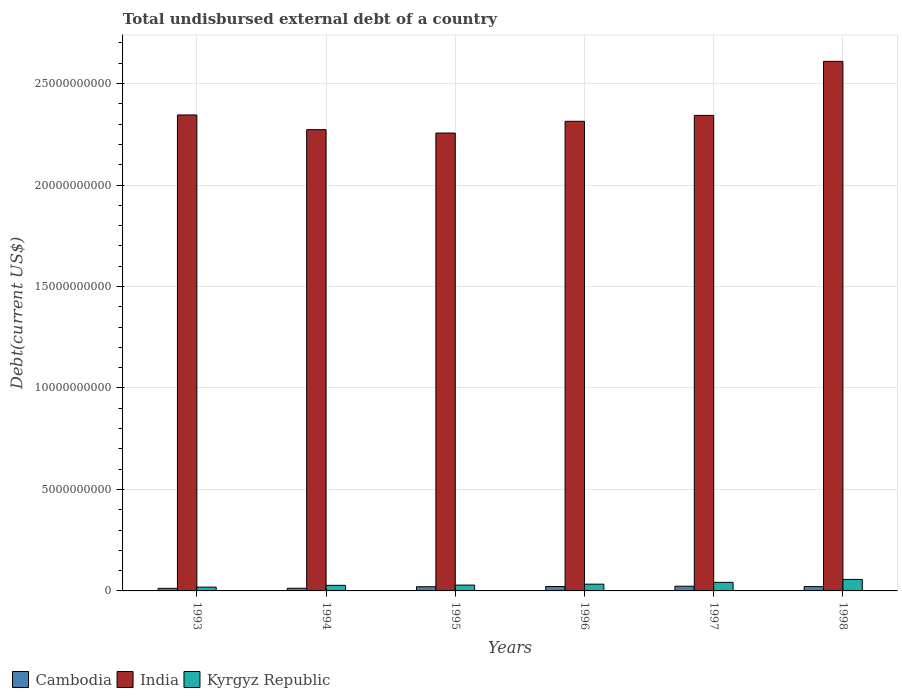How many different coloured bars are there?
Make the answer very short. 3. Are the number of bars per tick equal to the number of legend labels?
Offer a terse response. Yes. How many bars are there on the 3rd tick from the right?
Your answer should be compact. 3. What is the total undisbursed external debt in India in 1997?
Your answer should be very brief. 2.34e+1. Across all years, what is the maximum total undisbursed external debt in India?
Offer a terse response. 2.61e+1. Across all years, what is the minimum total undisbursed external debt in India?
Ensure brevity in your answer.  2.26e+1. In which year was the total undisbursed external debt in Kyrgyz Republic maximum?
Provide a short and direct response. 1998. In which year was the total undisbursed external debt in Cambodia minimum?
Give a very brief answer. 1993. What is the total total undisbursed external debt in India in the graph?
Give a very brief answer. 1.41e+11. What is the difference between the total undisbursed external debt in India in 1995 and that in 1998?
Your answer should be very brief. -3.53e+09. What is the difference between the total undisbursed external debt in Kyrgyz Republic in 1993 and the total undisbursed external debt in Cambodia in 1997?
Ensure brevity in your answer.  -4.32e+07. What is the average total undisbursed external debt in India per year?
Your answer should be compact. 2.36e+1. In the year 1993, what is the difference between the total undisbursed external debt in Kyrgyz Republic and total undisbursed external debt in Cambodia?
Your response must be concise. 6.01e+07. In how many years, is the total undisbursed external debt in Cambodia greater than 24000000000 US$?
Make the answer very short. 0. What is the ratio of the total undisbursed external debt in Cambodia in 1996 to that in 1998?
Give a very brief answer. 1.01. Is the total undisbursed external debt in Cambodia in 1994 less than that in 1998?
Your answer should be compact. Yes. Is the difference between the total undisbursed external debt in Kyrgyz Republic in 1997 and 1998 greater than the difference between the total undisbursed external debt in Cambodia in 1997 and 1998?
Give a very brief answer. No. What is the difference between the highest and the second highest total undisbursed external debt in India?
Offer a terse response. 2.64e+09. What is the difference between the highest and the lowest total undisbursed external debt in India?
Your answer should be compact. 3.53e+09. In how many years, is the total undisbursed external debt in India greater than the average total undisbursed external debt in India taken over all years?
Keep it short and to the point. 1. Is the sum of the total undisbursed external debt in India in 1994 and 1998 greater than the maximum total undisbursed external debt in Cambodia across all years?
Provide a short and direct response. Yes. What does the 1st bar from the left in 1993 represents?
Offer a very short reply. Cambodia. What does the 1st bar from the right in 1994 represents?
Provide a short and direct response. Kyrgyz Republic. Is it the case that in every year, the sum of the total undisbursed external debt in India and total undisbursed external debt in Cambodia is greater than the total undisbursed external debt in Kyrgyz Republic?
Your response must be concise. Yes. How many bars are there?
Provide a succinct answer. 18. Does the graph contain any zero values?
Your answer should be very brief. No. How many legend labels are there?
Provide a succinct answer. 3. What is the title of the graph?
Your answer should be compact. Total undisbursed external debt of a country. What is the label or title of the Y-axis?
Give a very brief answer. Debt(current US$). What is the Debt(current US$) of Cambodia in 1993?
Ensure brevity in your answer.  1.28e+08. What is the Debt(current US$) of India in 1993?
Ensure brevity in your answer.  2.35e+1. What is the Debt(current US$) of Kyrgyz Republic in 1993?
Keep it short and to the point. 1.88e+08. What is the Debt(current US$) in Cambodia in 1994?
Your answer should be very brief. 1.31e+08. What is the Debt(current US$) of India in 1994?
Your response must be concise. 2.27e+1. What is the Debt(current US$) in Kyrgyz Republic in 1994?
Make the answer very short. 2.75e+08. What is the Debt(current US$) in Cambodia in 1995?
Ensure brevity in your answer.  2.06e+08. What is the Debt(current US$) of India in 1995?
Provide a short and direct response. 2.26e+1. What is the Debt(current US$) of Kyrgyz Republic in 1995?
Ensure brevity in your answer.  2.88e+08. What is the Debt(current US$) of Cambodia in 1996?
Make the answer very short. 2.16e+08. What is the Debt(current US$) of India in 1996?
Your answer should be compact. 2.31e+1. What is the Debt(current US$) of Kyrgyz Republic in 1996?
Offer a very short reply. 3.33e+08. What is the Debt(current US$) of Cambodia in 1997?
Make the answer very short. 2.31e+08. What is the Debt(current US$) in India in 1997?
Provide a short and direct response. 2.34e+1. What is the Debt(current US$) in Kyrgyz Republic in 1997?
Provide a succinct answer. 4.22e+08. What is the Debt(current US$) in Cambodia in 1998?
Ensure brevity in your answer.  2.14e+08. What is the Debt(current US$) of India in 1998?
Your answer should be very brief. 2.61e+1. What is the Debt(current US$) in Kyrgyz Republic in 1998?
Your answer should be very brief. 5.67e+08. Across all years, what is the maximum Debt(current US$) in Cambodia?
Offer a terse response. 2.31e+08. Across all years, what is the maximum Debt(current US$) in India?
Your answer should be very brief. 2.61e+1. Across all years, what is the maximum Debt(current US$) of Kyrgyz Republic?
Ensure brevity in your answer.  5.67e+08. Across all years, what is the minimum Debt(current US$) in Cambodia?
Ensure brevity in your answer.  1.28e+08. Across all years, what is the minimum Debt(current US$) of India?
Your answer should be compact. 2.26e+1. Across all years, what is the minimum Debt(current US$) of Kyrgyz Republic?
Ensure brevity in your answer.  1.88e+08. What is the total Debt(current US$) of Cambodia in the graph?
Provide a short and direct response. 1.13e+09. What is the total Debt(current US$) in India in the graph?
Offer a very short reply. 1.41e+11. What is the total Debt(current US$) in Kyrgyz Republic in the graph?
Your answer should be compact. 2.07e+09. What is the difference between the Debt(current US$) of Cambodia in 1993 and that in 1994?
Offer a terse response. -3.66e+06. What is the difference between the Debt(current US$) of India in 1993 and that in 1994?
Offer a very short reply. 7.24e+08. What is the difference between the Debt(current US$) of Kyrgyz Republic in 1993 and that in 1994?
Offer a very short reply. -8.71e+07. What is the difference between the Debt(current US$) in Cambodia in 1993 and that in 1995?
Offer a very short reply. -7.79e+07. What is the difference between the Debt(current US$) in India in 1993 and that in 1995?
Provide a short and direct response. 8.91e+08. What is the difference between the Debt(current US$) of Kyrgyz Republic in 1993 and that in 1995?
Keep it short and to the point. -9.99e+07. What is the difference between the Debt(current US$) of Cambodia in 1993 and that in 1996?
Offer a terse response. -8.86e+07. What is the difference between the Debt(current US$) of India in 1993 and that in 1996?
Offer a terse response. 3.13e+08. What is the difference between the Debt(current US$) of Kyrgyz Republic in 1993 and that in 1996?
Your answer should be compact. -1.45e+08. What is the difference between the Debt(current US$) of Cambodia in 1993 and that in 1997?
Make the answer very short. -1.03e+08. What is the difference between the Debt(current US$) in India in 1993 and that in 1997?
Your response must be concise. 2.13e+07. What is the difference between the Debt(current US$) in Kyrgyz Republic in 1993 and that in 1997?
Provide a short and direct response. -2.35e+08. What is the difference between the Debt(current US$) in Cambodia in 1993 and that in 1998?
Your answer should be compact. -8.59e+07. What is the difference between the Debt(current US$) of India in 1993 and that in 1998?
Your answer should be compact. -2.64e+09. What is the difference between the Debt(current US$) in Kyrgyz Republic in 1993 and that in 1998?
Your answer should be very brief. -3.79e+08. What is the difference between the Debt(current US$) of Cambodia in 1994 and that in 1995?
Offer a very short reply. -7.42e+07. What is the difference between the Debt(current US$) of India in 1994 and that in 1995?
Give a very brief answer. 1.67e+08. What is the difference between the Debt(current US$) in Kyrgyz Republic in 1994 and that in 1995?
Keep it short and to the point. -1.28e+07. What is the difference between the Debt(current US$) of Cambodia in 1994 and that in 1996?
Your response must be concise. -8.50e+07. What is the difference between the Debt(current US$) in India in 1994 and that in 1996?
Ensure brevity in your answer.  -4.11e+08. What is the difference between the Debt(current US$) of Kyrgyz Republic in 1994 and that in 1996?
Your answer should be very brief. -5.80e+07. What is the difference between the Debt(current US$) of Cambodia in 1994 and that in 1997?
Offer a terse response. -9.96e+07. What is the difference between the Debt(current US$) in India in 1994 and that in 1997?
Give a very brief answer. -7.03e+08. What is the difference between the Debt(current US$) in Kyrgyz Republic in 1994 and that in 1997?
Offer a terse response. -1.48e+08. What is the difference between the Debt(current US$) of Cambodia in 1994 and that in 1998?
Make the answer very short. -8.22e+07. What is the difference between the Debt(current US$) of India in 1994 and that in 1998?
Provide a succinct answer. -3.37e+09. What is the difference between the Debt(current US$) in Kyrgyz Republic in 1994 and that in 1998?
Provide a succinct answer. -2.92e+08. What is the difference between the Debt(current US$) of Cambodia in 1995 and that in 1996?
Offer a very short reply. -1.07e+07. What is the difference between the Debt(current US$) of India in 1995 and that in 1996?
Keep it short and to the point. -5.79e+08. What is the difference between the Debt(current US$) of Kyrgyz Republic in 1995 and that in 1996?
Offer a terse response. -4.52e+07. What is the difference between the Debt(current US$) of Cambodia in 1995 and that in 1997?
Provide a succinct answer. -2.54e+07. What is the difference between the Debt(current US$) of India in 1995 and that in 1997?
Offer a terse response. -8.70e+08. What is the difference between the Debt(current US$) of Kyrgyz Republic in 1995 and that in 1997?
Keep it short and to the point. -1.35e+08. What is the difference between the Debt(current US$) in Cambodia in 1995 and that in 1998?
Make the answer very short. -7.99e+06. What is the difference between the Debt(current US$) of India in 1995 and that in 1998?
Give a very brief answer. -3.53e+09. What is the difference between the Debt(current US$) of Kyrgyz Republic in 1995 and that in 1998?
Your response must be concise. -2.79e+08. What is the difference between the Debt(current US$) in Cambodia in 1996 and that in 1997?
Make the answer very short. -1.47e+07. What is the difference between the Debt(current US$) of India in 1996 and that in 1997?
Keep it short and to the point. -2.91e+08. What is the difference between the Debt(current US$) in Kyrgyz Republic in 1996 and that in 1997?
Your response must be concise. -8.95e+07. What is the difference between the Debt(current US$) in Cambodia in 1996 and that in 1998?
Offer a terse response. 2.73e+06. What is the difference between the Debt(current US$) of India in 1996 and that in 1998?
Your answer should be compact. -2.95e+09. What is the difference between the Debt(current US$) in Kyrgyz Republic in 1996 and that in 1998?
Provide a succinct answer. -2.34e+08. What is the difference between the Debt(current US$) of Cambodia in 1997 and that in 1998?
Offer a very short reply. 1.74e+07. What is the difference between the Debt(current US$) of India in 1997 and that in 1998?
Your answer should be compact. -2.66e+09. What is the difference between the Debt(current US$) in Kyrgyz Republic in 1997 and that in 1998?
Keep it short and to the point. -1.44e+08. What is the difference between the Debt(current US$) of Cambodia in 1993 and the Debt(current US$) of India in 1994?
Make the answer very short. -2.26e+1. What is the difference between the Debt(current US$) of Cambodia in 1993 and the Debt(current US$) of Kyrgyz Republic in 1994?
Offer a terse response. -1.47e+08. What is the difference between the Debt(current US$) of India in 1993 and the Debt(current US$) of Kyrgyz Republic in 1994?
Provide a short and direct response. 2.32e+1. What is the difference between the Debt(current US$) of Cambodia in 1993 and the Debt(current US$) of India in 1995?
Offer a terse response. -2.24e+1. What is the difference between the Debt(current US$) in Cambodia in 1993 and the Debt(current US$) in Kyrgyz Republic in 1995?
Ensure brevity in your answer.  -1.60e+08. What is the difference between the Debt(current US$) in India in 1993 and the Debt(current US$) in Kyrgyz Republic in 1995?
Offer a terse response. 2.32e+1. What is the difference between the Debt(current US$) in Cambodia in 1993 and the Debt(current US$) in India in 1996?
Make the answer very short. -2.30e+1. What is the difference between the Debt(current US$) in Cambodia in 1993 and the Debt(current US$) in Kyrgyz Republic in 1996?
Give a very brief answer. -2.05e+08. What is the difference between the Debt(current US$) of India in 1993 and the Debt(current US$) of Kyrgyz Republic in 1996?
Provide a short and direct response. 2.31e+1. What is the difference between the Debt(current US$) in Cambodia in 1993 and the Debt(current US$) in India in 1997?
Offer a very short reply. -2.33e+1. What is the difference between the Debt(current US$) in Cambodia in 1993 and the Debt(current US$) in Kyrgyz Republic in 1997?
Your answer should be very brief. -2.95e+08. What is the difference between the Debt(current US$) of India in 1993 and the Debt(current US$) of Kyrgyz Republic in 1997?
Give a very brief answer. 2.30e+1. What is the difference between the Debt(current US$) of Cambodia in 1993 and the Debt(current US$) of India in 1998?
Offer a terse response. -2.60e+1. What is the difference between the Debt(current US$) of Cambodia in 1993 and the Debt(current US$) of Kyrgyz Republic in 1998?
Offer a very short reply. -4.39e+08. What is the difference between the Debt(current US$) in India in 1993 and the Debt(current US$) in Kyrgyz Republic in 1998?
Offer a terse response. 2.29e+1. What is the difference between the Debt(current US$) of Cambodia in 1994 and the Debt(current US$) of India in 1995?
Your answer should be compact. -2.24e+1. What is the difference between the Debt(current US$) of Cambodia in 1994 and the Debt(current US$) of Kyrgyz Republic in 1995?
Give a very brief answer. -1.56e+08. What is the difference between the Debt(current US$) in India in 1994 and the Debt(current US$) in Kyrgyz Republic in 1995?
Give a very brief answer. 2.24e+1. What is the difference between the Debt(current US$) of Cambodia in 1994 and the Debt(current US$) of India in 1996?
Your answer should be very brief. -2.30e+1. What is the difference between the Debt(current US$) of Cambodia in 1994 and the Debt(current US$) of Kyrgyz Republic in 1996?
Provide a short and direct response. -2.02e+08. What is the difference between the Debt(current US$) of India in 1994 and the Debt(current US$) of Kyrgyz Republic in 1996?
Offer a terse response. 2.24e+1. What is the difference between the Debt(current US$) of Cambodia in 1994 and the Debt(current US$) of India in 1997?
Offer a very short reply. -2.33e+1. What is the difference between the Debt(current US$) in Cambodia in 1994 and the Debt(current US$) in Kyrgyz Republic in 1997?
Provide a succinct answer. -2.91e+08. What is the difference between the Debt(current US$) of India in 1994 and the Debt(current US$) of Kyrgyz Republic in 1997?
Your response must be concise. 2.23e+1. What is the difference between the Debt(current US$) in Cambodia in 1994 and the Debt(current US$) in India in 1998?
Offer a terse response. -2.60e+1. What is the difference between the Debt(current US$) in Cambodia in 1994 and the Debt(current US$) in Kyrgyz Republic in 1998?
Give a very brief answer. -4.36e+08. What is the difference between the Debt(current US$) of India in 1994 and the Debt(current US$) of Kyrgyz Republic in 1998?
Your answer should be very brief. 2.22e+1. What is the difference between the Debt(current US$) of Cambodia in 1995 and the Debt(current US$) of India in 1996?
Provide a succinct answer. -2.29e+1. What is the difference between the Debt(current US$) in Cambodia in 1995 and the Debt(current US$) in Kyrgyz Republic in 1996?
Keep it short and to the point. -1.27e+08. What is the difference between the Debt(current US$) in India in 1995 and the Debt(current US$) in Kyrgyz Republic in 1996?
Your answer should be very brief. 2.22e+1. What is the difference between the Debt(current US$) of Cambodia in 1995 and the Debt(current US$) of India in 1997?
Offer a terse response. -2.32e+1. What is the difference between the Debt(current US$) of Cambodia in 1995 and the Debt(current US$) of Kyrgyz Republic in 1997?
Give a very brief answer. -2.17e+08. What is the difference between the Debt(current US$) in India in 1995 and the Debt(current US$) in Kyrgyz Republic in 1997?
Offer a terse response. 2.21e+1. What is the difference between the Debt(current US$) in Cambodia in 1995 and the Debt(current US$) in India in 1998?
Ensure brevity in your answer.  -2.59e+1. What is the difference between the Debt(current US$) of Cambodia in 1995 and the Debt(current US$) of Kyrgyz Republic in 1998?
Your response must be concise. -3.61e+08. What is the difference between the Debt(current US$) in India in 1995 and the Debt(current US$) in Kyrgyz Republic in 1998?
Provide a succinct answer. 2.20e+1. What is the difference between the Debt(current US$) of Cambodia in 1996 and the Debt(current US$) of India in 1997?
Give a very brief answer. -2.32e+1. What is the difference between the Debt(current US$) in Cambodia in 1996 and the Debt(current US$) in Kyrgyz Republic in 1997?
Make the answer very short. -2.06e+08. What is the difference between the Debt(current US$) of India in 1996 and the Debt(current US$) of Kyrgyz Republic in 1997?
Your response must be concise. 2.27e+1. What is the difference between the Debt(current US$) in Cambodia in 1996 and the Debt(current US$) in India in 1998?
Offer a terse response. -2.59e+1. What is the difference between the Debt(current US$) in Cambodia in 1996 and the Debt(current US$) in Kyrgyz Republic in 1998?
Offer a very short reply. -3.51e+08. What is the difference between the Debt(current US$) in India in 1996 and the Debt(current US$) in Kyrgyz Republic in 1998?
Provide a succinct answer. 2.26e+1. What is the difference between the Debt(current US$) of Cambodia in 1997 and the Debt(current US$) of India in 1998?
Give a very brief answer. -2.59e+1. What is the difference between the Debt(current US$) in Cambodia in 1997 and the Debt(current US$) in Kyrgyz Republic in 1998?
Keep it short and to the point. -3.36e+08. What is the difference between the Debt(current US$) of India in 1997 and the Debt(current US$) of Kyrgyz Republic in 1998?
Offer a terse response. 2.29e+1. What is the average Debt(current US$) of Cambodia per year?
Offer a very short reply. 1.88e+08. What is the average Debt(current US$) in India per year?
Your answer should be compact. 2.36e+1. What is the average Debt(current US$) in Kyrgyz Republic per year?
Your response must be concise. 3.45e+08. In the year 1993, what is the difference between the Debt(current US$) in Cambodia and Debt(current US$) in India?
Keep it short and to the point. -2.33e+1. In the year 1993, what is the difference between the Debt(current US$) in Cambodia and Debt(current US$) in Kyrgyz Republic?
Your answer should be very brief. -6.01e+07. In the year 1993, what is the difference between the Debt(current US$) in India and Debt(current US$) in Kyrgyz Republic?
Ensure brevity in your answer.  2.33e+1. In the year 1994, what is the difference between the Debt(current US$) of Cambodia and Debt(current US$) of India?
Keep it short and to the point. -2.26e+1. In the year 1994, what is the difference between the Debt(current US$) in Cambodia and Debt(current US$) in Kyrgyz Republic?
Make the answer very short. -1.43e+08. In the year 1994, what is the difference between the Debt(current US$) of India and Debt(current US$) of Kyrgyz Republic?
Your answer should be very brief. 2.25e+1. In the year 1995, what is the difference between the Debt(current US$) in Cambodia and Debt(current US$) in India?
Provide a succinct answer. -2.24e+1. In the year 1995, what is the difference between the Debt(current US$) in Cambodia and Debt(current US$) in Kyrgyz Republic?
Provide a short and direct response. -8.21e+07. In the year 1995, what is the difference between the Debt(current US$) in India and Debt(current US$) in Kyrgyz Republic?
Provide a short and direct response. 2.23e+1. In the year 1996, what is the difference between the Debt(current US$) of Cambodia and Debt(current US$) of India?
Offer a very short reply. -2.29e+1. In the year 1996, what is the difference between the Debt(current US$) of Cambodia and Debt(current US$) of Kyrgyz Republic?
Your response must be concise. -1.17e+08. In the year 1996, what is the difference between the Debt(current US$) in India and Debt(current US$) in Kyrgyz Republic?
Your answer should be compact. 2.28e+1. In the year 1997, what is the difference between the Debt(current US$) of Cambodia and Debt(current US$) of India?
Offer a terse response. -2.32e+1. In the year 1997, what is the difference between the Debt(current US$) in Cambodia and Debt(current US$) in Kyrgyz Republic?
Keep it short and to the point. -1.91e+08. In the year 1997, what is the difference between the Debt(current US$) of India and Debt(current US$) of Kyrgyz Republic?
Provide a succinct answer. 2.30e+1. In the year 1998, what is the difference between the Debt(current US$) of Cambodia and Debt(current US$) of India?
Keep it short and to the point. -2.59e+1. In the year 1998, what is the difference between the Debt(current US$) in Cambodia and Debt(current US$) in Kyrgyz Republic?
Provide a short and direct response. -3.53e+08. In the year 1998, what is the difference between the Debt(current US$) in India and Debt(current US$) in Kyrgyz Republic?
Give a very brief answer. 2.55e+1. What is the ratio of the Debt(current US$) in Cambodia in 1993 to that in 1994?
Give a very brief answer. 0.97. What is the ratio of the Debt(current US$) of India in 1993 to that in 1994?
Your answer should be compact. 1.03. What is the ratio of the Debt(current US$) in Kyrgyz Republic in 1993 to that in 1994?
Your answer should be very brief. 0.68. What is the ratio of the Debt(current US$) in Cambodia in 1993 to that in 1995?
Ensure brevity in your answer.  0.62. What is the ratio of the Debt(current US$) in India in 1993 to that in 1995?
Your response must be concise. 1.04. What is the ratio of the Debt(current US$) of Kyrgyz Republic in 1993 to that in 1995?
Provide a succinct answer. 0.65. What is the ratio of the Debt(current US$) in Cambodia in 1993 to that in 1996?
Give a very brief answer. 0.59. What is the ratio of the Debt(current US$) in India in 1993 to that in 1996?
Provide a succinct answer. 1.01. What is the ratio of the Debt(current US$) of Kyrgyz Republic in 1993 to that in 1996?
Make the answer very short. 0.56. What is the ratio of the Debt(current US$) in Cambodia in 1993 to that in 1997?
Your answer should be very brief. 0.55. What is the ratio of the Debt(current US$) of Kyrgyz Republic in 1993 to that in 1997?
Give a very brief answer. 0.44. What is the ratio of the Debt(current US$) of Cambodia in 1993 to that in 1998?
Offer a very short reply. 0.6. What is the ratio of the Debt(current US$) of India in 1993 to that in 1998?
Make the answer very short. 0.9. What is the ratio of the Debt(current US$) in Kyrgyz Republic in 1993 to that in 1998?
Your response must be concise. 0.33. What is the ratio of the Debt(current US$) in Cambodia in 1994 to that in 1995?
Provide a short and direct response. 0.64. What is the ratio of the Debt(current US$) of India in 1994 to that in 1995?
Provide a short and direct response. 1.01. What is the ratio of the Debt(current US$) of Kyrgyz Republic in 1994 to that in 1995?
Provide a succinct answer. 0.96. What is the ratio of the Debt(current US$) in Cambodia in 1994 to that in 1996?
Provide a short and direct response. 0.61. What is the ratio of the Debt(current US$) in India in 1994 to that in 1996?
Your answer should be compact. 0.98. What is the ratio of the Debt(current US$) in Kyrgyz Republic in 1994 to that in 1996?
Give a very brief answer. 0.83. What is the ratio of the Debt(current US$) of Cambodia in 1994 to that in 1997?
Provide a succinct answer. 0.57. What is the ratio of the Debt(current US$) in India in 1994 to that in 1997?
Keep it short and to the point. 0.97. What is the ratio of the Debt(current US$) of Kyrgyz Republic in 1994 to that in 1997?
Offer a terse response. 0.65. What is the ratio of the Debt(current US$) of Cambodia in 1994 to that in 1998?
Your answer should be very brief. 0.62. What is the ratio of the Debt(current US$) in India in 1994 to that in 1998?
Your answer should be compact. 0.87. What is the ratio of the Debt(current US$) in Kyrgyz Republic in 1994 to that in 1998?
Keep it short and to the point. 0.48. What is the ratio of the Debt(current US$) of Cambodia in 1995 to that in 1996?
Your answer should be very brief. 0.95. What is the ratio of the Debt(current US$) in Kyrgyz Republic in 1995 to that in 1996?
Your response must be concise. 0.86. What is the ratio of the Debt(current US$) of Cambodia in 1995 to that in 1997?
Your answer should be very brief. 0.89. What is the ratio of the Debt(current US$) of India in 1995 to that in 1997?
Offer a very short reply. 0.96. What is the ratio of the Debt(current US$) in Kyrgyz Republic in 1995 to that in 1997?
Provide a short and direct response. 0.68. What is the ratio of the Debt(current US$) in Cambodia in 1995 to that in 1998?
Give a very brief answer. 0.96. What is the ratio of the Debt(current US$) of India in 1995 to that in 1998?
Provide a succinct answer. 0.86. What is the ratio of the Debt(current US$) in Kyrgyz Republic in 1995 to that in 1998?
Give a very brief answer. 0.51. What is the ratio of the Debt(current US$) in Cambodia in 1996 to that in 1997?
Offer a terse response. 0.94. What is the ratio of the Debt(current US$) in India in 1996 to that in 1997?
Your response must be concise. 0.99. What is the ratio of the Debt(current US$) in Kyrgyz Republic in 1996 to that in 1997?
Your answer should be compact. 0.79. What is the ratio of the Debt(current US$) in Cambodia in 1996 to that in 1998?
Offer a very short reply. 1.01. What is the ratio of the Debt(current US$) in India in 1996 to that in 1998?
Provide a succinct answer. 0.89. What is the ratio of the Debt(current US$) of Kyrgyz Republic in 1996 to that in 1998?
Offer a terse response. 0.59. What is the ratio of the Debt(current US$) in Cambodia in 1997 to that in 1998?
Give a very brief answer. 1.08. What is the ratio of the Debt(current US$) in India in 1997 to that in 1998?
Your answer should be very brief. 0.9. What is the ratio of the Debt(current US$) in Kyrgyz Republic in 1997 to that in 1998?
Your answer should be compact. 0.75. What is the difference between the highest and the second highest Debt(current US$) of Cambodia?
Offer a very short reply. 1.47e+07. What is the difference between the highest and the second highest Debt(current US$) of India?
Your answer should be compact. 2.64e+09. What is the difference between the highest and the second highest Debt(current US$) of Kyrgyz Republic?
Your answer should be very brief. 1.44e+08. What is the difference between the highest and the lowest Debt(current US$) of Cambodia?
Keep it short and to the point. 1.03e+08. What is the difference between the highest and the lowest Debt(current US$) of India?
Your answer should be very brief. 3.53e+09. What is the difference between the highest and the lowest Debt(current US$) of Kyrgyz Republic?
Ensure brevity in your answer.  3.79e+08. 